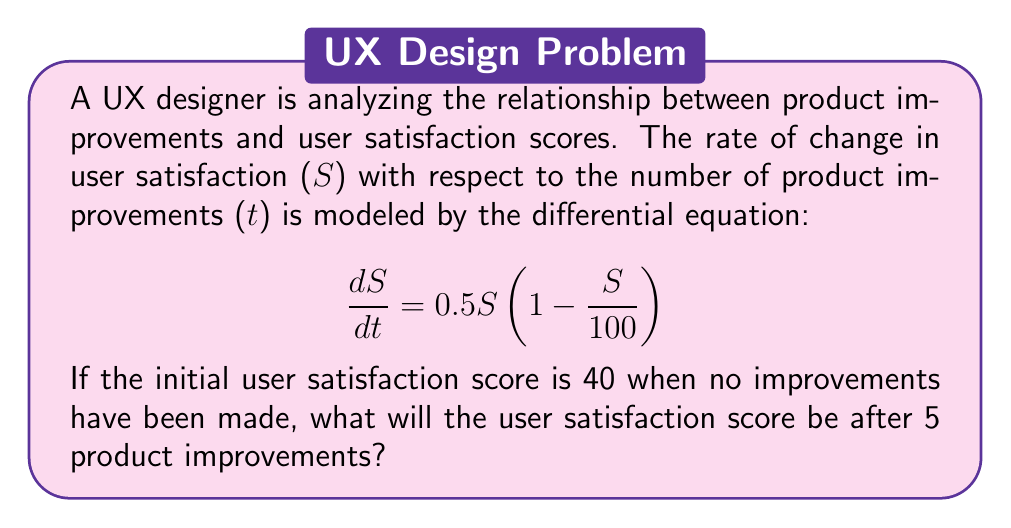Show me your answer to this math problem. To solve this problem, we need to use the given first-order differential equation and apply the separation of variables method:

1. Separate the variables:
   $$\frac{dS}{S(1 - \frac{S}{100})} = 0.5dt$$

2. Integrate both sides:
   $$\int \frac{dS}{S(1 - \frac{S}{100})} = \int 0.5dt$$

3. Solve the left-hand side using partial fractions:
   $$\int (\frac{1}{S} + \frac{1}{100 - S})dS = 0.5t + C$$

4. Evaluate the integral:
   $$\ln|S| - \ln|100 - S| = 0.5t + C$$

5. Simplify:
   $$\ln|\frac{S}{100 - S}| = 0.5t + C$$

6. Apply the initial condition $S(0) = 40$:
   $$\ln|\frac{40}{60}| = C$$
   $$C = \ln|\frac{2}{3}|$$

7. Substitute back into the general solution:
   $$\ln|\frac{S}{100 - S}| = 0.5t + \ln|\frac{2}{3}|$$

8. Simplify and solve for $S$:
   $$\frac{S}{100 - S} = \frac{2}{3}e^{0.5t}$$
   $$S = \frac{200e^{0.5t}}{3 + e^{0.5t}}$$

9. Calculate $S$ when $t = 5$:
   $$S(5) = \frac{200e^{0.5(5)}}{3 + e^{0.5(5)}} \approx 86.47$$

Therefore, after 5 product improvements, the user satisfaction score will be approximately 86.47.
Answer: $S(5) \approx 86.47$ 